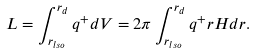<formula> <loc_0><loc_0><loc_500><loc_500>L = \int _ { r _ { l s o } } ^ { r _ { d } } q ^ { + } d V = 2 \pi \int _ { r _ { l s o } } ^ { r _ { d } } q ^ { + } r H d r .</formula> 